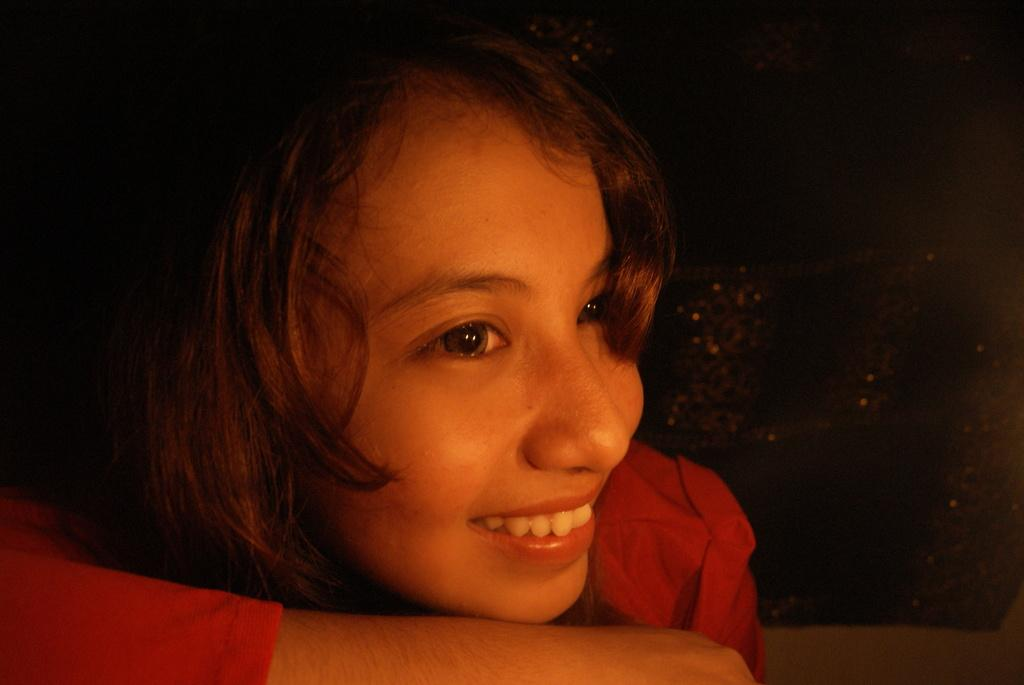Who is present in the image? There is a person in the image. What is the person wearing? The person is wearing a red dress. What can be observed about the background of the image? The background of the image is dark. What is the person's grandmother doing in the image? There is no mention of a grandmother in the image, so it cannot be determined what the person's grandmother might be doing. 